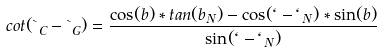Convert formula to latex. <formula><loc_0><loc_0><loc_500><loc_500>c o t ( \theta _ { C } - \theta _ { G } ) = \frac { \cos ( b ) * t a n ( b _ { N } ) - \cos ( \ell - \ell _ { N } ) * \sin ( b ) } { \sin ( \ell - \ell _ { N } ) }</formula> 